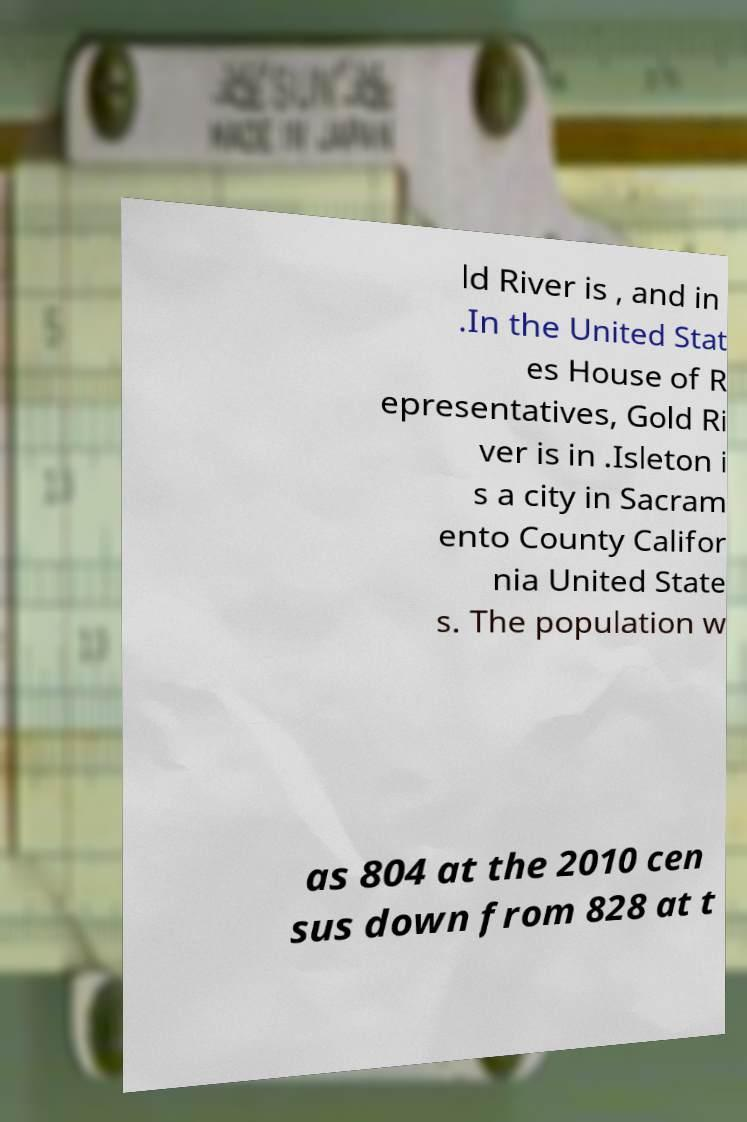Can you read and provide the text displayed in the image?This photo seems to have some interesting text. Can you extract and type it out for me? ld River is , and in .In the United Stat es House of R epresentatives, Gold Ri ver is in .Isleton i s a city in Sacram ento County Califor nia United State s. The population w as 804 at the 2010 cen sus down from 828 at t 